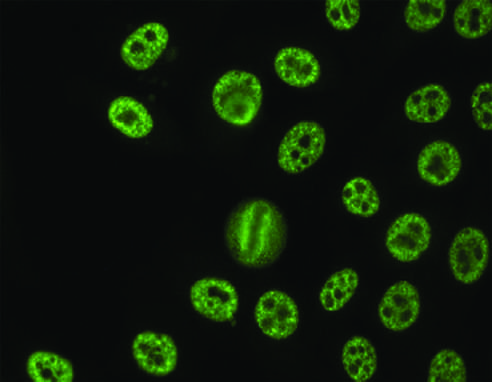what is a speckled pattern seen with?
Answer the question using a single word or phrase. Antibodies against various nuclear antigens 